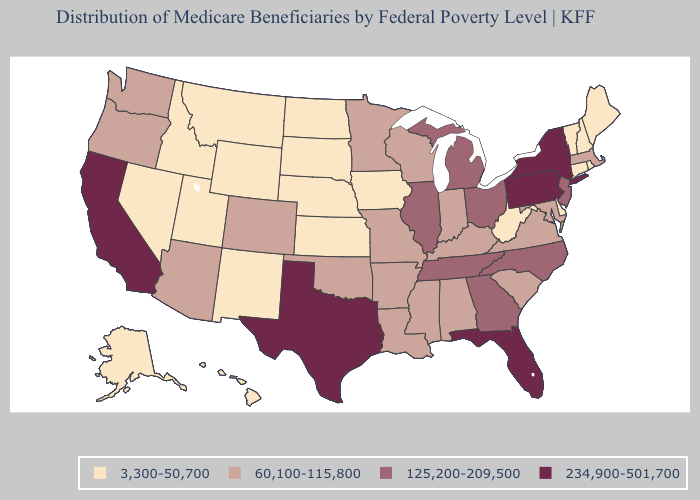Does the first symbol in the legend represent the smallest category?
Be succinct. Yes. Does Wisconsin have the highest value in the USA?
Short answer required. No. Does Idaho have a lower value than Connecticut?
Quick response, please. No. Which states have the lowest value in the USA?
Keep it brief. Alaska, Connecticut, Delaware, Hawaii, Idaho, Iowa, Kansas, Maine, Montana, Nebraska, Nevada, New Hampshire, New Mexico, North Dakota, Rhode Island, South Dakota, Utah, Vermont, West Virginia, Wyoming. Does Connecticut have a lower value than West Virginia?
Answer briefly. No. Name the states that have a value in the range 3,300-50,700?
Concise answer only. Alaska, Connecticut, Delaware, Hawaii, Idaho, Iowa, Kansas, Maine, Montana, Nebraska, Nevada, New Hampshire, New Mexico, North Dakota, Rhode Island, South Dakota, Utah, Vermont, West Virginia, Wyoming. How many symbols are there in the legend?
Answer briefly. 4. Name the states that have a value in the range 60,100-115,800?
Keep it brief. Alabama, Arizona, Arkansas, Colorado, Indiana, Kentucky, Louisiana, Maryland, Massachusetts, Minnesota, Mississippi, Missouri, Oklahoma, Oregon, South Carolina, Virginia, Washington, Wisconsin. Which states hav the highest value in the South?
Give a very brief answer. Florida, Texas. Name the states that have a value in the range 125,200-209,500?
Keep it brief. Georgia, Illinois, Michigan, New Jersey, North Carolina, Ohio, Tennessee. Name the states that have a value in the range 234,900-501,700?
Write a very short answer. California, Florida, New York, Pennsylvania, Texas. What is the lowest value in the USA?
Answer briefly. 3,300-50,700. Which states have the highest value in the USA?
Concise answer only. California, Florida, New York, Pennsylvania, Texas. What is the lowest value in the USA?
Write a very short answer. 3,300-50,700. Name the states that have a value in the range 125,200-209,500?
Keep it brief. Georgia, Illinois, Michigan, New Jersey, North Carolina, Ohio, Tennessee. 